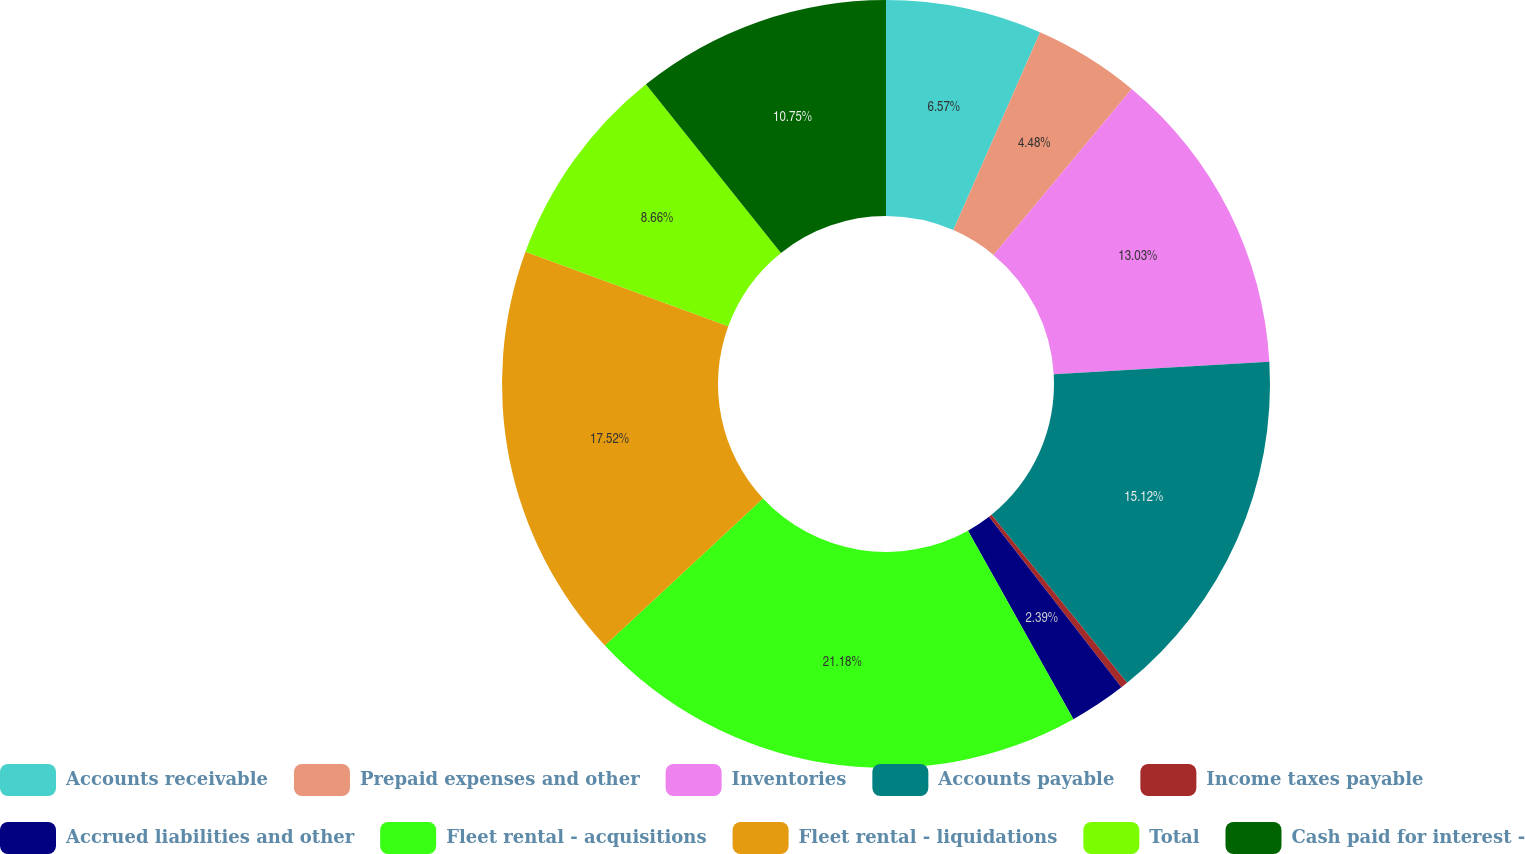<chart> <loc_0><loc_0><loc_500><loc_500><pie_chart><fcel>Accounts receivable<fcel>Prepaid expenses and other<fcel>Inventories<fcel>Accounts payable<fcel>Income taxes payable<fcel>Accrued liabilities and other<fcel>Fleet rental - acquisitions<fcel>Fleet rental - liquidations<fcel>Total<fcel>Cash paid for interest -<nl><fcel>6.57%<fcel>4.48%<fcel>13.03%<fcel>15.12%<fcel>0.3%<fcel>2.39%<fcel>21.19%<fcel>17.52%<fcel>8.66%<fcel>10.75%<nl></chart> 